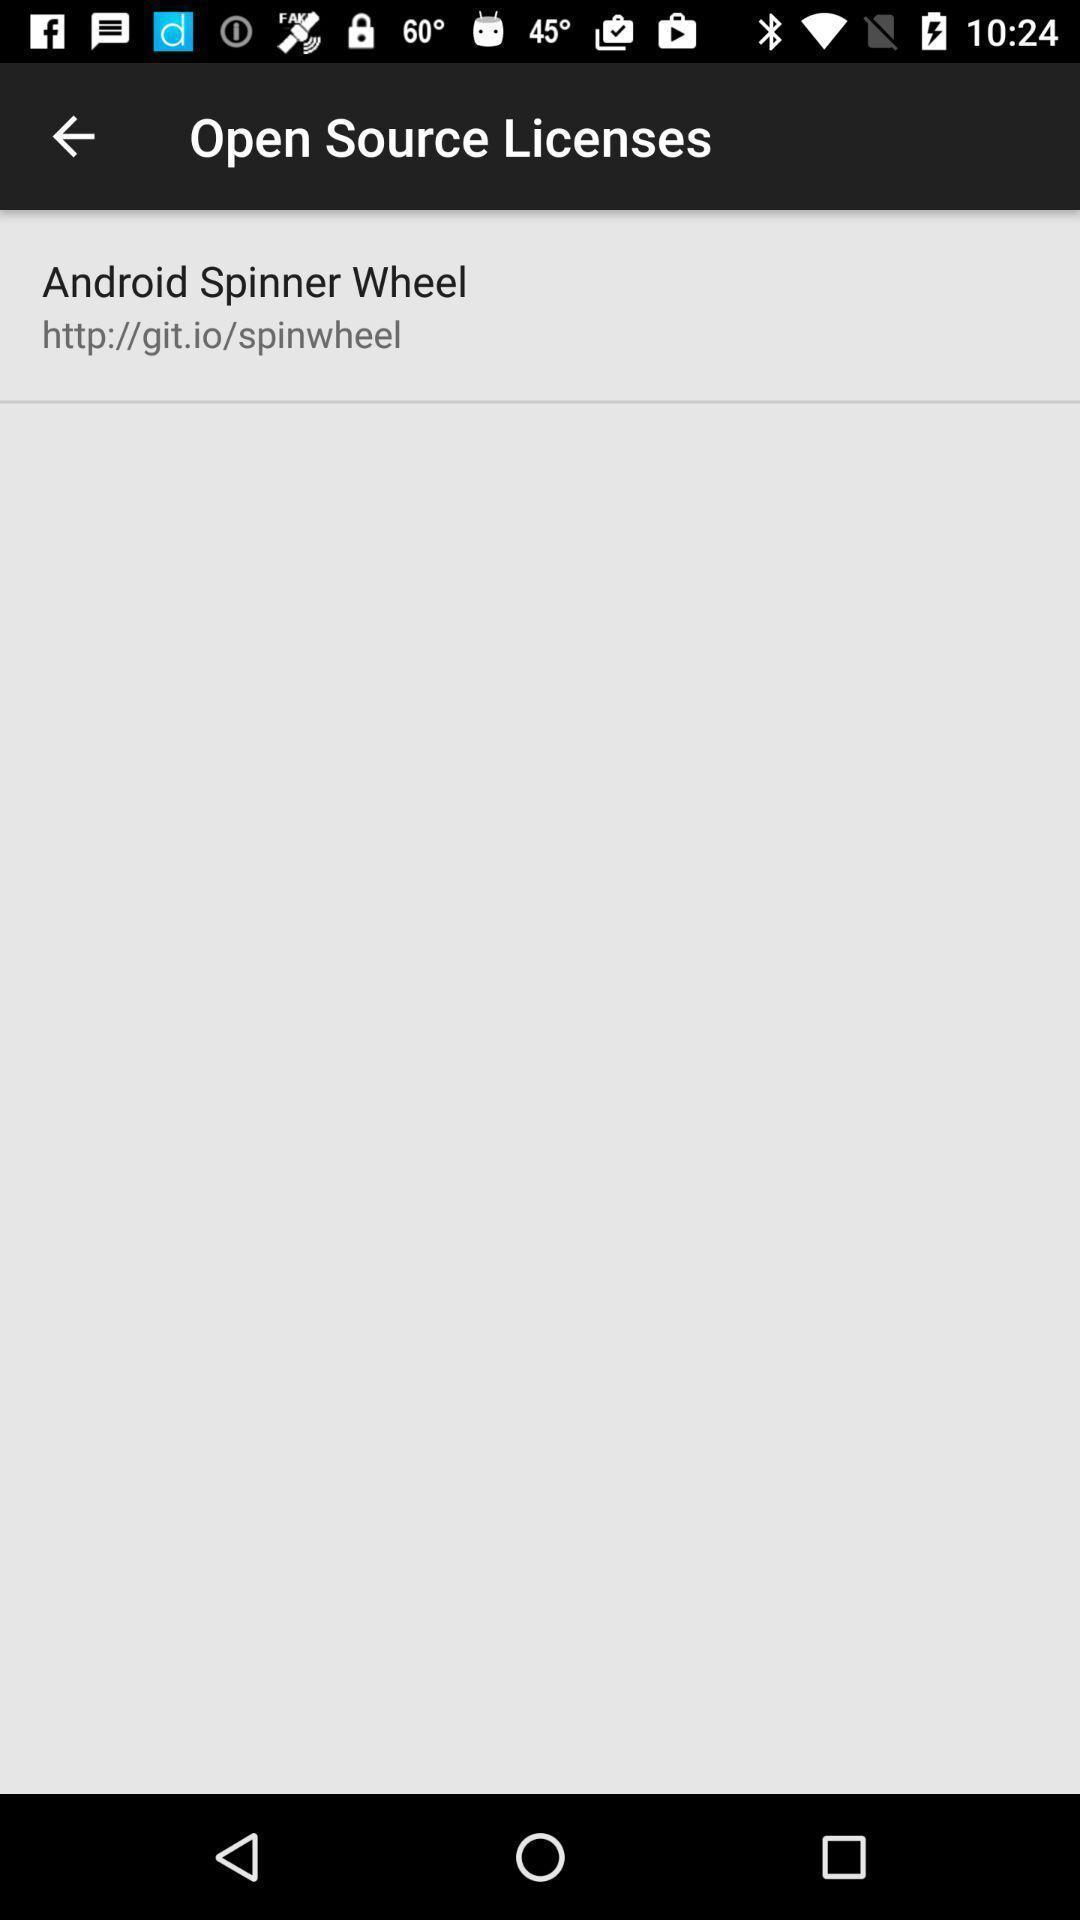Give me a narrative description of this picture. Page showing open source licenses. 